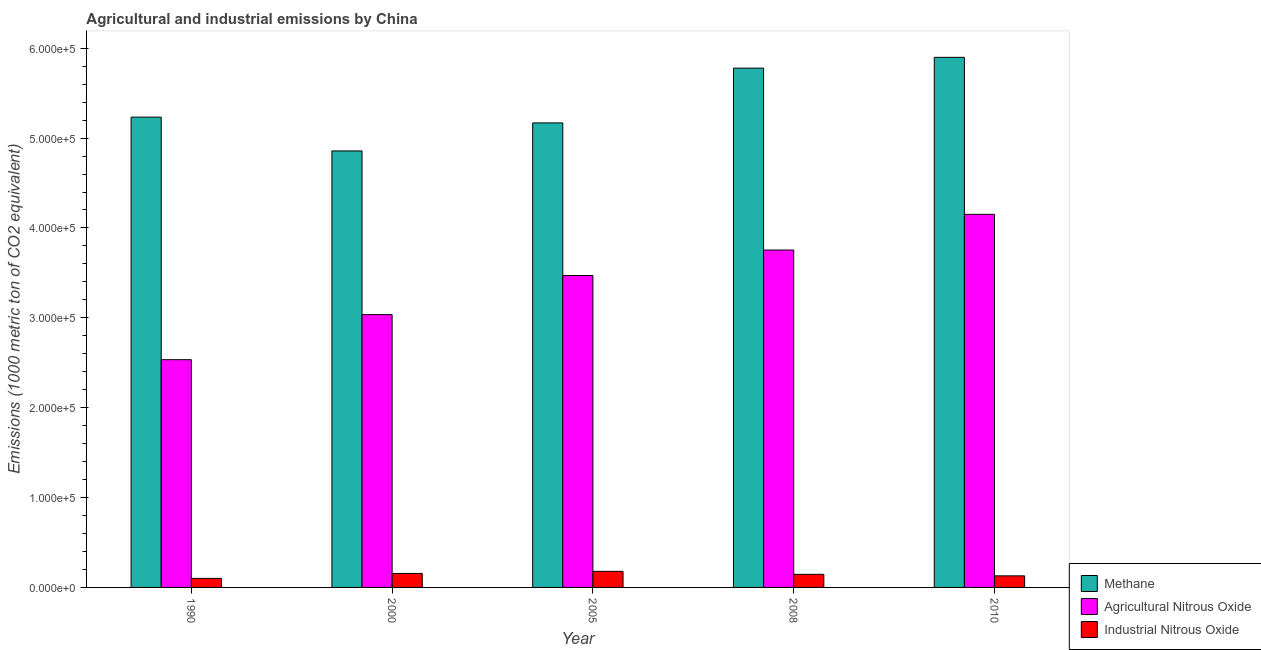Are the number of bars per tick equal to the number of legend labels?
Offer a very short reply. Yes. Are the number of bars on each tick of the X-axis equal?
Make the answer very short. Yes. What is the amount of methane emissions in 2000?
Offer a very short reply. 4.86e+05. Across all years, what is the maximum amount of agricultural nitrous oxide emissions?
Keep it short and to the point. 4.15e+05. Across all years, what is the minimum amount of industrial nitrous oxide emissions?
Your answer should be compact. 1.01e+04. What is the total amount of agricultural nitrous oxide emissions in the graph?
Make the answer very short. 1.69e+06. What is the difference between the amount of agricultural nitrous oxide emissions in 1990 and that in 2000?
Your answer should be compact. -5.02e+04. What is the difference between the amount of agricultural nitrous oxide emissions in 2008 and the amount of industrial nitrous oxide emissions in 2005?
Your response must be concise. 2.83e+04. What is the average amount of agricultural nitrous oxide emissions per year?
Ensure brevity in your answer.  3.39e+05. What is the ratio of the amount of agricultural nitrous oxide emissions in 2000 to that in 2010?
Ensure brevity in your answer.  0.73. Is the difference between the amount of agricultural nitrous oxide emissions in 2000 and 2010 greater than the difference between the amount of industrial nitrous oxide emissions in 2000 and 2010?
Provide a succinct answer. No. What is the difference between the highest and the second highest amount of industrial nitrous oxide emissions?
Make the answer very short. 2336.7. What is the difference between the highest and the lowest amount of methane emissions?
Your response must be concise. 1.04e+05. In how many years, is the amount of industrial nitrous oxide emissions greater than the average amount of industrial nitrous oxide emissions taken over all years?
Give a very brief answer. 3. What does the 1st bar from the left in 2008 represents?
Your answer should be very brief. Methane. What does the 3rd bar from the right in 2005 represents?
Ensure brevity in your answer.  Methane. How many years are there in the graph?
Offer a very short reply. 5. What is the difference between two consecutive major ticks on the Y-axis?
Ensure brevity in your answer.  1.00e+05. Are the values on the major ticks of Y-axis written in scientific E-notation?
Keep it short and to the point. Yes. How many legend labels are there?
Keep it short and to the point. 3. What is the title of the graph?
Offer a very short reply. Agricultural and industrial emissions by China. Does "Ages 65 and above" appear as one of the legend labels in the graph?
Your answer should be compact. No. What is the label or title of the Y-axis?
Your answer should be very brief. Emissions (1000 metric ton of CO2 equivalent). What is the Emissions (1000 metric ton of CO2 equivalent) in Methane in 1990?
Your answer should be compact. 5.23e+05. What is the Emissions (1000 metric ton of CO2 equivalent) in Agricultural Nitrous Oxide in 1990?
Keep it short and to the point. 2.53e+05. What is the Emissions (1000 metric ton of CO2 equivalent) of Industrial Nitrous Oxide in 1990?
Your answer should be very brief. 1.01e+04. What is the Emissions (1000 metric ton of CO2 equivalent) of Methane in 2000?
Offer a very short reply. 4.86e+05. What is the Emissions (1000 metric ton of CO2 equivalent) of Agricultural Nitrous Oxide in 2000?
Provide a short and direct response. 3.04e+05. What is the Emissions (1000 metric ton of CO2 equivalent) in Industrial Nitrous Oxide in 2000?
Give a very brief answer. 1.56e+04. What is the Emissions (1000 metric ton of CO2 equivalent) of Methane in 2005?
Provide a succinct answer. 5.17e+05. What is the Emissions (1000 metric ton of CO2 equivalent) of Agricultural Nitrous Oxide in 2005?
Make the answer very short. 3.47e+05. What is the Emissions (1000 metric ton of CO2 equivalent) in Industrial Nitrous Oxide in 2005?
Keep it short and to the point. 1.79e+04. What is the Emissions (1000 metric ton of CO2 equivalent) of Methane in 2008?
Your answer should be compact. 5.78e+05. What is the Emissions (1000 metric ton of CO2 equivalent) in Agricultural Nitrous Oxide in 2008?
Ensure brevity in your answer.  3.75e+05. What is the Emissions (1000 metric ton of CO2 equivalent) of Industrial Nitrous Oxide in 2008?
Offer a very short reply. 1.46e+04. What is the Emissions (1000 metric ton of CO2 equivalent) in Methane in 2010?
Give a very brief answer. 5.90e+05. What is the Emissions (1000 metric ton of CO2 equivalent) of Agricultural Nitrous Oxide in 2010?
Ensure brevity in your answer.  4.15e+05. What is the Emissions (1000 metric ton of CO2 equivalent) in Industrial Nitrous Oxide in 2010?
Offer a terse response. 1.29e+04. Across all years, what is the maximum Emissions (1000 metric ton of CO2 equivalent) of Methane?
Provide a short and direct response. 5.90e+05. Across all years, what is the maximum Emissions (1000 metric ton of CO2 equivalent) of Agricultural Nitrous Oxide?
Your answer should be very brief. 4.15e+05. Across all years, what is the maximum Emissions (1000 metric ton of CO2 equivalent) of Industrial Nitrous Oxide?
Your answer should be very brief. 1.79e+04. Across all years, what is the minimum Emissions (1000 metric ton of CO2 equivalent) of Methane?
Your answer should be compact. 4.86e+05. Across all years, what is the minimum Emissions (1000 metric ton of CO2 equivalent) in Agricultural Nitrous Oxide?
Provide a succinct answer. 2.53e+05. Across all years, what is the minimum Emissions (1000 metric ton of CO2 equivalent) of Industrial Nitrous Oxide?
Provide a succinct answer. 1.01e+04. What is the total Emissions (1000 metric ton of CO2 equivalent) of Methane in the graph?
Provide a short and direct response. 2.69e+06. What is the total Emissions (1000 metric ton of CO2 equivalent) of Agricultural Nitrous Oxide in the graph?
Offer a very short reply. 1.69e+06. What is the total Emissions (1000 metric ton of CO2 equivalent) of Industrial Nitrous Oxide in the graph?
Provide a short and direct response. 7.10e+04. What is the difference between the Emissions (1000 metric ton of CO2 equivalent) in Methane in 1990 and that in 2000?
Provide a short and direct response. 3.76e+04. What is the difference between the Emissions (1000 metric ton of CO2 equivalent) of Agricultural Nitrous Oxide in 1990 and that in 2000?
Offer a terse response. -5.02e+04. What is the difference between the Emissions (1000 metric ton of CO2 equivalent) of Industrial Nitrous Oxide in 1990 and that in 2000?
Provide a succinct answer. -5513.6. What is the difference between the Emissions (1000 metric ton of CO2 equivalent) of Methane in 1990 and that in 2005?
Give a very brief answer. 6449.7. What is the difference between the Emissions (1000 metric ton of CO2 equivalent) of Agricultural Nitrous Oxide in 1990 and that in 2005?
Provide a succinct answer. -9.37e+04. What is the difference between the Emissions (1000 metric ton of CO2 equivalent) in Industrial Nitrous Oxide in 1990 and that in 2005?
Make the answer very short. -7850.3. What is the difference between the Emissions (1000 metric ton of CO2 equivalent) in Methane in 1990 and that in 2008?
Ensure brevity in your answer.  -5.45e+04. What is the difference between the Emissions (1000 metric ton of CO2 equivalent) in Agricultural Nitrous Oxide in 1990 and that in 2008?
Give a very brief answer. -1.22e+05. What is the difference between the Emissions (1000 metric ton of CO2 equivalent) of Industrial Nitrous Oxide in 1990 and that in 2008?
Give a very brief answer. -4502.8. What is the difference between the Emissions (1000 metric ton of CO2 equivalent) of Methane in 1990 and that in 2010?
Provide a succinct answer. -6.65e+04. What is the difference between the Emissions (1000 metric ton of CO2 equivalent) of Agricultural Nitrous Oxide in 1990 and that in 2010?
Your answer should be very brief. -1.62e+05. What is the difference between the Emissions (1000 metric ton of CO2 equivalent) of Industrial Nitrous Oxide in 1990 and that in 2010?
Ensure brevity in your answer.  -2830.9. What is the difference between the Emissions (1000 metric ton of CO2 equivalent) in Methane in 2000 and that in 2005?
Offer a terse response. -3.12e+04. What is the difference between the Emissions (1000 metric ton of CO2 equivalent) of Agricultural Nitrous Oxide in 2000 and that in 2005?
Provide a succinct answer. -4.35e+04. What is the difference between the Emissions (1000 metric ton of CO2 equivalent) of Industrial Nitrous Oxide in 2000 and that in 2005?
Your answer should be very brief. -2336.7. What is the difference between the Emissions (1000 metric ton of CO2 equivalent) in Methane in 2000 and that in 2008?
Your answer should be very brief. -9.21e+04. What is the difference between the Emissions (1000 metric ton of CO2 equivalent) of Agricultural Nitrous Oxide in 2000 and that in 2008?
Give a very brief answer. -7.19e+04. What is the difference between the Emissions (1000 metric ton of CO2 equivalent) of Industrial Nitrous Oxide in 2000 and that in 2008?
Provide a short and direct response. 1010.8. What is the difference between the Emissions (1000 metric ton of CO2 equivalent) of Methane in 2000 and that in 2010?
Offer a very short reply. -1.04e+05. What is the difference between the Emissions (1000 metric ton of CO2 equivalent) of Agricultural Nitrous Oxide in 2000 and that in 2010?
Keep it short and to the point. -1.12e+05. What is the difference between the Emissions (1000 metric ton of CO2 equivalent) in Industrial Nitrous Oxide in 2000 and that in 2010?
Provide a succinct answer. 2682.7. What is the difference between the Emissions (1000 metric ton of CO2 equivalent) of Methane in 2005 and that in 2008?
Offer a very short reply. -6.10e+04. What is the difference between the Emissions (1000 metric ton of CO2 equivalent) of Agricultural Nitrous Oxide in 2005 and that in 2008?
Your response must be concise. -2.83e+04. What is the difference between the Emissions (1000 metric ton of CO2 equivalent) in Industrial Nitrous Oxide in 2005 and that in 2008?
Provide a succinct answer. 3347.5. What is the difference between the Emissions (1000 metric ton of CO2 equivalent) of Methane in 2005 and that in 2010?
Give a very brief answer. -7.30e+04. What is the difference between the Emissions (1000 metric ton of CO2 equivalent) of Agricultural Nitrous Oxide in 2005 and that in 2010?
Offer a very short reply. -6.81e+04. What is the difference between the Emissions (1000 metric ton of CO2 equivalent) in Industrial Nitrous Oxide in 2005 and that in 2010?
Your answer should be compact. 5019.4. What is the difference between the Emissions (1000 metric ton of CO2 equivalent) of Methane in 2008 and that in 2010?
Provide a succinct answer. -1.20e+04. What is the difference between the Emissions (1000 metric ton of CO2 equivalent) of Agricultural Nitrous Oxide in 2008 and that in 2010?
Ensure brevity in your answer.  -3.97e+04. What is the difference between the Emissions (1000 metric ton of CO2 equivalent) of Industrial Nitrous Oxide in 2008 and that in 2010?
Ensure brevity in your answer.  1671.9. What is the difference between the Emissions (1000 metric ton of CO2 equivalent) of Methane in 1990 and the Emissions (1000 metric ton of CO2 equivalent) of Agricultural Nitrous Oxide in 2000?
Your answer should be very brief. 2.20e+05. What is the difference between the Emissions (1000 metric ton of CO2 equivalent) of Methane in 1990 and the Emissions (1000 metric ton of CO2 equivalent) of Industrial Nitrous Oxide in 2000?
Provide a succinct answer. 5.08e+05. What is the difference between the Emissions (1000 metric ton of CO2 equivalent) in Agricultural Nitrous Oxide in 1990 and the Emissions (1000 metric ton of CO2 equivalent) in Industrial Nitrous Oxide in 2000?
Offer a very short reply. 2.38e+05. What is the difference between the Emissions (1000 metric ton of CO2 equivalent) in Methane in 1990 and the Emissions (1000 metric ton of CO2 equivalent) in Agricultural Nitrous Oxide in 2005?
Offer a very short reply. 1.76e+05. What is the difference between the Emissions (1000 metric ton of CO2 equivalent) in Methane in 1990 and the Emissions (1000 metric ton of CO2 equivalent) in Industrial Nitrous Oxide in 2005?
Keep it short and to the point. 5.05e+05. What is the difference between the Emissions (1000 metric ton of CO2 equivalent) in Agricultural Nitrous Oxide in 1990 and the Emissions (1000 metric ton of CO2 equivalent) in Industrial Nitrous Oxide in 2005?
Your response must be concise. 2.35e+05. What is the difference between the Emissions (1000 metric ton of CO2 equivalent) of Methane in 1990 and the Emissions (1000 metric ton of CO2 equivalent) of Agricultural Nitrous Oxide in 2008?
Provide a short and direct response. 1.48e+05. What is the difference between the Emissions (1000 metric ton of CO2 equivalent) in Methane in 1990 and the Emissions (1000 metric ton of CO2 equivalent) in Industrial Nitrous Oxide in 2008?
Your response must be concise. 5.09e+05. What is the difference between the Emissions (1000 metric ton of CO2 equivalent) in Agricultural Nitrous Oxide in 1990 and the Emissions (1000 metric ton of CO2 equivalent) in Industrial Nitrous Oxide in 2008?
Offer a terse response. 2.39e+05. What is the difference between the Emissions (1000 metric ton of CO2 equivalent) in Methane in 1990 and the Emissions (1000 metric ton of CO2 equivalent) in Agricultural Nitrous Oxide in 2010?
Give a very brief answer. 1.08e+05. What is the difference between the Emissions (1000 metric ton of CO2 equivalent) in Methane in 1990 and the Emissions (1000 metric ton of CO2 equivalent) in Industrial Nitrous Oxide in 2010?
Your answer should be compact. 5.10e+05. What is the difference between the Emissions (1000 metric ton of CO2 equivalent) in Agricultural Nitrous Oxide in 1990 and the Emissions (1000 metric ton of CO2 equivalent) in Industrial Nitrous Oxide in 2010?
Make the answer very short. 2.41e+05. What is the difference between the Emissions (1000 metric ton of CO2 equivalent) in Methane in 2000 and the Emissions (1000 metric ton of CO2 equivalent) in Agricultural Nitrous Oxide in 2005?
Your answer should be compact. 1.39e+05. What is the difference between the Emissions (1000 metric ton of CO2 equivalent) of Methane in 2000 and the Emissions (1000 metric ton of CO2 equivalent) of Industrial Nitrous Oxide in 2005?
Provide a short and direct response. 4.68e+05. What is the difference between the Emissions (1000 metric ton of CO2 equivalent) of Agricultural Nitrous Oxide in 2000 and the Emissions (1000 metric ton of CO2 equivalent) of Industrial Nitrous Oxide in 2005?
Make the answer very short. 2.86e+05. What is the difference between the Emissions (1000 metric ton of CO2 equivalent) in Methane in 2000 and the Emissions (1000 metric ton of CO2 equivalent) in Agricultural Nitrous Oxide in 2008?
Offer a terse response. 1.10e+05. What is the difference between the Emissions (1000 metric ton of CO2 equivalent) in Methane in 2000 and the Emissions (1000 metric ton of CO2 equivalent) in Industrial Nitrous Oxide in 2008?
Ensure brevity in your answer.  4.71e+05. What is the difference between the Emissions (1000 metric ton of CO2 equivalent) in Agricultural Nitrous Oxide in 2000 and the Emissions (1000 metric ton of CO2 equivalent) in Industrial Nitrous Oxide in 2008?
Ensure brevity in your answer.  2.89e+05. What is the difference between the Emissions (1000 metric ton of CO2 equivalent) of Methane in 2000 and the Emissions (1000 metric ton of CO2 equivalent) of Agricultural Nitrous Oxide in 2010?
Your response must be concise. 7.06e+04. What is the difference between the Emissions (1000 metric ton of CO2 equivalent) of Methane in 2000 and the Emissions (1000 metric ton of CO2 equivalent) of Industrial Nitrous Oxide in 2010?
Provide a succinct answer. 4.73e+05. What is the difference between the Emissions (1000 metric ton of CO2 equivalent) in Agricultural Nitrous Oxide in 2000 and the Emissions (1000 metric ton of CO2 equivalent) in Industrial Nitrous Oxide in 2010?
Ensure brevity in your answer.  2.91e+05. What is the difference between the Emissions (1000 metric ton of CO2 equivalent) in Methane in 2005 and the Emissions (1000 metric ton of CO2 equivalent) in Agricultural Nitrous Oxide in 2008?
Provide a succinct answer. 1.41e+05. What is the difference between the Emissions (1000 metric ton of CO2 equivalent) in Methane in 2005 and the Emissions (1000 metric ton of CO2 equivalent) in Industrial Nitrous Oxide in 2008?
Ensure brevity in your answer.  5.02e+05. What is the difference between the Emissions (1000 metric ton of CO2 equivalent) in Agricultural Nitrous Oxide in 2005 and the Emissions (1000 metric ton of CO2 equivalent) in Industrial Nitrous Oxide in 2008?
Your answer should be compact. 3.33e+05. What is the difference between the Emissions (1000 metric ton of CO2 equivalent) in Methane in 2005 and the Emissions (1000 metric ton of CO2 equivalent) in Agricultural Nitrous Oxide in 2010?
Give a very brief answer. 1.02e+05. What is the difference between the Emissions (1000 metric ton of CO2 equivalent) of Methane in 2005 and the Emissions (1000 metric ton of CO2 equivalent) of Industrial Nitrous Oxide in 2010?
Your answer should be compact. 5.04e+05. What is the difference between the Emissions (1000 metric ton of CO2 equivalent) in Agricultural Nitrous Oxide in 2005 and the Emissions (1000 metric ton of CO2 equivalent) in Industrial Nitrous Oxide in 2010?
Keep it short and to the point. 3.34e+05. What is the difference between the Emissions (1000 metric ton of CO2 equivalent) in Methane in 2008 and the Emissions (1000 metric ton of CO2 equivalent) in Agricultural Nitrous Oxide in 2010?
Make the answer very short. 1.63e+05. What is the difference between the Emissions (1000 metric ton of CO2 equivalent) in Methane in 2008 and the Emissions (1000 metric ton of CO2 equivalent) in Industrial Nitrous Oxide in 2010?
Give a very brief answer. 5.65e+05. What is the difference between the Emissions (1000 metric ton of CO2 equivalent) of Agricultural Nitrous Oxide in 2008 and the Emissions (1000 metric ton of CO2 equivalent) of Industrial Nitrous Oxide in 2010?
Offer a terse response. 3.63e+05. What is the average Emissions (1000 metric ton of CO2 equivalent) of Methane per year?
Offer a very short reply. 5.39e+05. What is the average Emissions (1000 metric ton of CO2 equivalent) of Agricultural Nitrous Oxide per year?
Offer a terse response. 3.39e+05. What is the average Emissions (1000 metric ton of CO2 equivalent) in Industrial Nitrous Oxide per year?
Ensure brevity in your answer.  1.42e+04. In the year 1990, what is the difference between the Emissions (1000 metric ton of CO2 equivalent) of Methane and Emissions (1000 metric ton of CO2 equivalent) of Agricultural Nitrous Oxide?
Provide a short and direct response. 2.70e+05. In the year 1990, what is the difference between the Emissions (1000 metric ton of CO2 equivalent) in Methane and Emissions (1000 metric ton of CO2 equivalent) in Industrial Nitrous Oxide?
Offer a terse response. 5.13e+05. In the year 1990, what is the difference between the Emissions (1000 metric ton of CO2 equivalent) of Agricultural Nitrous Oxide and Emissions (1000 metric ton of CO2 equivalent) of Industrial Nitrous Oxide?
Your answer should be compact. 2.43e+05. In the year 2000, what is the difference between the Emissions (1000 metric ton of CO2 equivalent) in Methane and Emissions (1000 metric ton of CO2 equivalent) in Agricultural Nitrous Oxide?
Give a very brief answer. 1.82e+05. In the year 2000, what is the difference between the Emissions (1000 metric ton of CO2 equivalent) of Methane and Emissions (1000 metric ton of CO2 equivalent) of Industrial Nitrous Oxide?
Provide a succinct answer. 4.70e+05. In the year 2000, what is the difference between the Emissions (1000 metric ton of CO2 equivalent) of Agricultural Nitrous Oxide and Emissions (1000 metric ton of CO2 equivalent) of Industrial Nitrous Oxide?
Provide a short and direct response. 2.88e+05. In the year 2005, what is the difference between the Emissions (1000 metric ton of CO2 equivalent) in Methane and Emissions (1000 metric ton of CO2 equivalent) in Agricultural Nitrous Oxide?
Ensure brevity in your answer.  1.70e+05. In the year 2005, what is the difference between the Emissions (1000 metric ton of CO2 equivalent) of Methane and Emissions (1000 metric ton of CO2 equivalent) of Industrial Nitrous Oxide?
Give a very brief answer. 4.99e+05. In the year 2005, what is the difference between the Emissions (1000 metric ton of CO2 equivalent) of Agricultural Nitrous Oxide and Emissions (1000 metric ton of CO2 equivalent) of Industrial Nitrous Oxide?
Offer a terse response. 3.29e+05. In the year 2008, what is the difference between the Emissions (1000 metric ton of CO2 equivalent) of Methane and Emissions (1000 metric ton of CO2 equivalent) of Agricultural Nitrous Oxide?
Make the answer very short. 2.02e+05. In the year 2008, what is the difference between the Emissions (1000 metric ton of CO2 equivalent) of Methane and Emissions (1000 metric ton of CO2 equivalent) of Industrial Nitrous Oxide?
Provide a short and direct response. 5.63e+05. In the year 2008, what is the difference between the Emissions (1000 metric ton of CO2 equivalent) of Agricultural Nitrous Oxide and Emissions (1000 metric ton of CO2 equivalent) of Industrial Nitrous Oxide?
Provide a short and direct response. 3.61e+05. In the year 2010, what is the difference between the Emissions (1000 metric ton of CO2 equivalent) of Methane and Emissions (1000 metric ton of CO2 equivalent) of Agricultural Nitrous Oxide?
Keep it short and to the point. 1.75e+05. In the year 2010, what is the difference between the Emissions (1000 metric ton of CO2 equivalent) of Methane and Emissions (1000 metric ton of CO2 equivalent) of Industrial Nitrous Oxide?
Offer a very short reply. 5.77e+05. In the year 2010, what is the difference between the Emissions (1000 metric ton of CO2 equivalent) in Agricultural Nitrous Oxide and Emissions (1000 metric ton of CO2 equivalent) in Industrial Nitrous Oxide?
Your answer should be very brief. 4.02e+05. What is the ratio of the Emissions (1000 metric ton of CO2 equivalent) of Methane in 1990 to that in 2000?
Keep it short and to the point. 1.08. What is the ratio of the Emissions (1000 metric ton of CO2 equivalent) in Agricultural Nitrous Oxide in 1990 to that in 2000?
Make the answer very short. 0.83. What is the ratio of the Emissions (1000 metric ton of CO2 equivalent) of Industrial Nitrous Oxide in 1990 to that in 2000?
Give a very brief answer. 0.65. What is the ratio of the Emissions (1000 metric ton of CO2 equivalent) in Methane in 1990 to that in 2005?
Keep it short and to the point. 1.01. What is the ratio of the Emissions (1000 metric ton of CO2 equivalent) in Agricultural Nitrous Oxide in 1990 to that in 2005?
Your response must be concise. 0.73. What is the ratio of the Emissions (1000 metric ton of CO2 equivalent) in Industrial Nitrous Oxide in 1990 to that in 2005?
Your answer should be very brief. 0.56. What is the ratio of the Emissions (1000 metric ton of CO2 equivalent) in Methane in 1990 to that in 2008?
Keep it short and to the point. 0.91. What is the ratio of the Emissions (1000 metric ton of CO2 equivalent) of Agricultural Nitrous Oxide in 1990 to that in 2008?
Ensure brevity in your answer.  0.68. What is the ratio of the Emissions (1000 metric ton of CO2 equivalent) in Industrial Nitrous Oxide in 1990 to that in 2008?
Your response must be concise. 0.69. What is the ratio of the Emissions (1000 metric ton of CO2 equivalent) in Methane in 1990 to that in 2010?
Your response must be concise. 0.89. What is the ratio of the Emissions (1000 metric ton of CO2 equivalent) of Agricultural Nitrous Oxide in 1990 to that in 2010?
Provide a short and direct response. 0.61. What is the ratio of the Emissions (1000 metric ton of CO2 equivalent) of Industrial Nitrous Oxide in 1990 to that in 2010?
Give a very brief answer. 0.78. What is the ratio of the Emissions (1000 metric ton of CO2 equivalent) of Methane in 2000 to that in 2005?
Ensure brevity in your answer.  0.94. What is the ratio of the Emissions (1000 metric ton of CO2 equivalent) in Agricultural Nitrous Oxide in 2000 to that in 2005?
Ensure brevity in your answer.  0.87. What is the ratio of the Emissions (1000 metric ton of CO2 equivalent) of Industrial Nitrous Oxide in 2000 to that in 2005?
Your response must be concise. 0.87. What is the ratio of the Emissions (1000 metric ton of CO2 equivalent) in Methane in 2000 to that in 2008?
Offer a very short reply. 0.84. What is the ratio of the Emissions (1000 metric ton of CO2 equivalent) in Agricultural Nitrous Oxide in 2000 to that in 2008?
Provide a succinct answer. 0.81. What is the ratio of the Emissions (1000 metric ton of CO2 equivalent) of Industrial Nitrous Oxide in 2000 to that in 2008?
Provide a short and direct response. 1.07. What is the ratio of the Emissions (1000 metric ton of CO2 equivalent) in Methane in 2000 to that in 2010?
Offer a very short reply. 0.82. What is the ratio of the Emissions (1000 metric ton of CO2 equivalent) in Agricultural Nitrous Oxide in 2000 to that in 2010?
Give a very brief answer. 0.73. What is the ratio of the Emissions (1000 metric ton of CO2 equivalent) in Industrial Nitrous Oxide in 2000 to that in 2010?
Make the answer very short. 1.21. What is the ratio of the Emissions (1000 metric ton of CO2 equivalent) of Methane in 2005 to that in 2008?
Give a very brief answer. 0.89. What is the ratio of the Emissions (1000 metric ton of CO2 equivalent) of Agricultural Nitrous Oxide in 2005 to that in 2008?
Ensure brevity in your answer.  0.92. What is the ratio of the Emissions (1000 metric ton of CO2 equivalent) of Industrial Nitrous Oxide in 2005 to that in 2008?
Offer a very short reply. 1.23. What is the ratio of the Emissions (1000 metric ton of CO2 equivalent) of Methane in 2005 to that in 2010?
Provide a succinct answer. 0.88. What is the ratio of the Emissions (1000 metric ton of CO2 equivalent) in Agricultural Nitrous Oxide in 2005 to that in 2010?
Ensure brevity in your answer.  0.84. What is the ratio of the Emissions (1000 metric ton of CO2 equivalent) in Industrial Nitrous Oxide in 2005 to that in 2010?
Offer a terse response. 1.39. What is the ratio of the Emissions (1000 metric ton of CO2 equivalent) of Methane in 2008 to that in 2010?
Your answer should be compact. 0.98. What is the ratio of the Emissions (1000 metric ton of CO2 equivalent) of Agricultural Nitrous Oxide in 2008 to that in 2010?
Give a very brief answer. 0.9. What is the ratio of the Emissions (1000 metric ton of CO2 equivalent) in Industrial Nitrous Oxide in 2008 to that in 2010?
Provide a succinct answer. 1.13. What is the difference between the highest and the second highest Emissions (1000 metric ton of CO2 equivalent) of Methane?
Offer a very short reply. 1.20e+04. What is the difference between the highest and the second highest Emissions (1000 metric ton of CO2 equivalent) of Agricultural Nitrous Oxide?
Your answer should be compact. 3.97e+04. What is the difference between the highest and the second highest Emissions (1000 metric ton of CO2 equivalent) in Industrial Nitrous Oxide?
Provide a short and direct response. 2336.7. What is the difference between the highest and the lowest Emissions (1000 metric ton of CO2 equivalent) of Methane?
Your answer should be compact. 1.04e+05. What is the difference between the highest and the lowest Emissions (1000 metric ton of CO2 equivalent) in Agricultural Nitrous Oxide?
Offer a terse response. 1.62e+05. What is the difference between the highest and the lowest Emissions (1000 metric ton of CO2 equivalent) of Industrial Nitrous Oxide?
Offer a very short reply. 7850.3. 